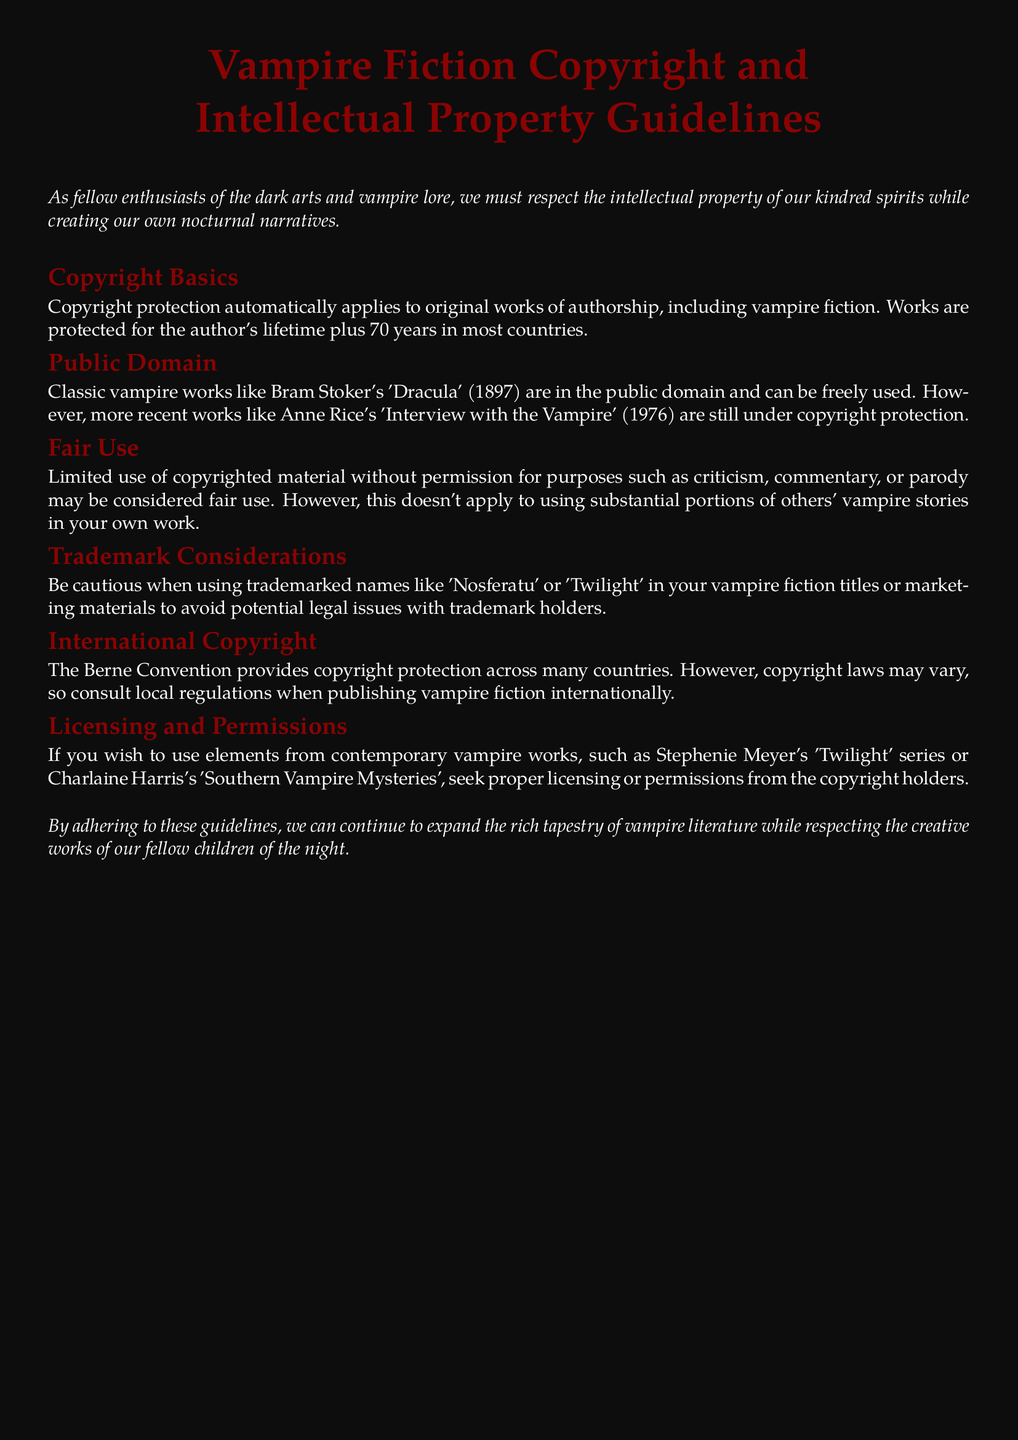What is the copyright duration for original works? Copyright protection lasts for the author's lifetime plus 70 years in most countries.
Answer: 70 years Which classic vampire work is mentioned as being in the public domain? Bram Stoker's 'Dracula' (1897) is listed as being in the public domain.
Answer: 'Dracula' What term is used to describe limited use of copyrighted material for criticism or parody? The term described is 'fair use'.
Answer: fair use What is a trademark consideration mentioned for vampire fiction titles? Caution is advised when using trademarked names like 'Nosferatu' or 'Twilight'.
Answer: trademarked names Which convention provides copyright protection across many countries? The Berne Convention is mentioned as providing copyright protection.
Answer: Berne Convention What should authors seek for using elements from contemporary vampire works? Authors should seek proper licensing or permissions from copyright holders.
Answer: licensing or permissions Which publication year is given for 'Interview with the Vampire'? The year given for 'Interview with the Vampire' is 1976.
Answer: 1976 What color is used for the document's title? The document's title uses the color bloodred.
Answer: bloodred What is advised for publishing vampire fiction internationally? Consulting local regulations is advised for international publishing.
Answer: local regulations 